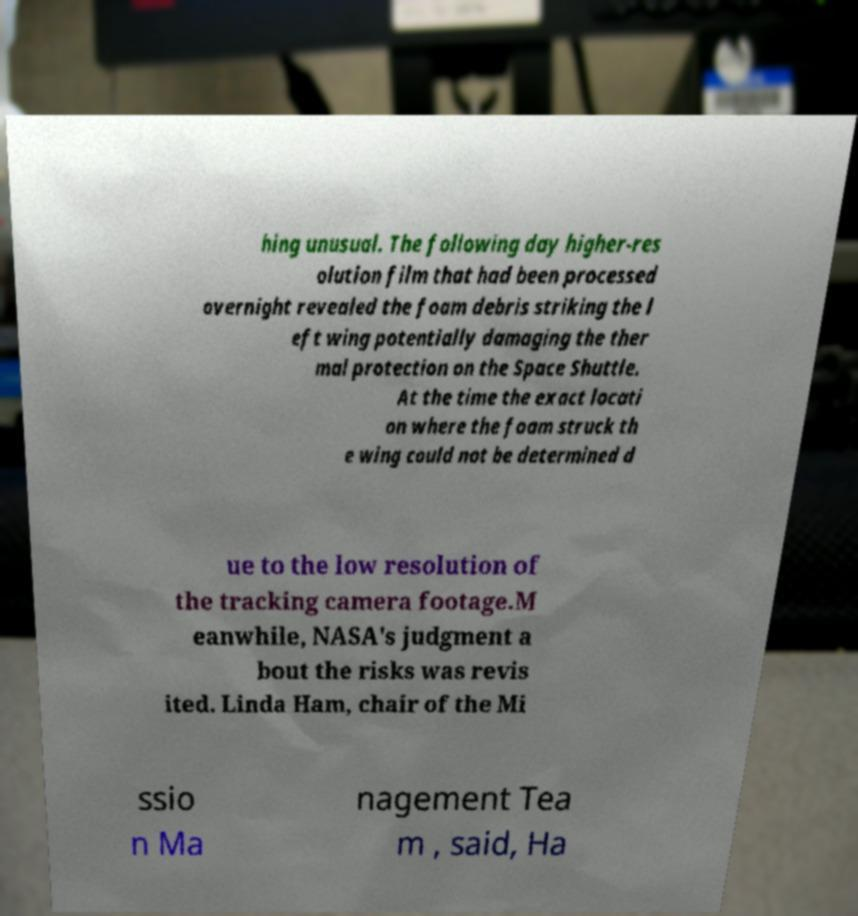Please read and relay the text visible in this image. What does it say? hing unusual. The following day higher-res olution film that had been processed overnight revealed the foam debris striking the l eft wing potentially damaging the ther mal protection on the Space Shuttle. At the time the exact locati on where the foam struck th e wing could not be determined d ue to the low resolution of the tracking camera footage.M eanwhile, NASA's judgment a bout the risks was revis ited. Linda Ham, chair of the Mi ssio n Ma nagement Tea m , said, Ha 